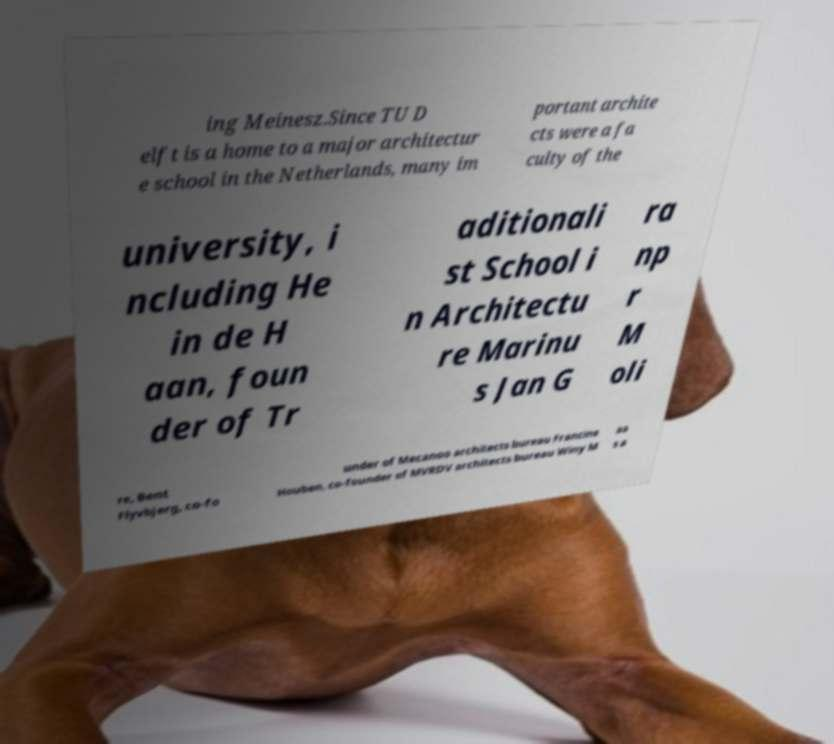What messages or text are displayed in this image? I need them in a readable, typed format. ing Meinesz.Since TU D elft is a home to a major architectur e school in the Netherlands, many im portant archite cts were a fa culty of the university, i ncluding He in de H aan, foun der of Tr aditionali st School i n Architectu re Marinu s Jan G ra np r M oli re, Bent Flyvbjerg, co-fo under of Mecanoo architects bureau Francine Houben, co-founder of MVRDV architects bureau Winy M aa s a 